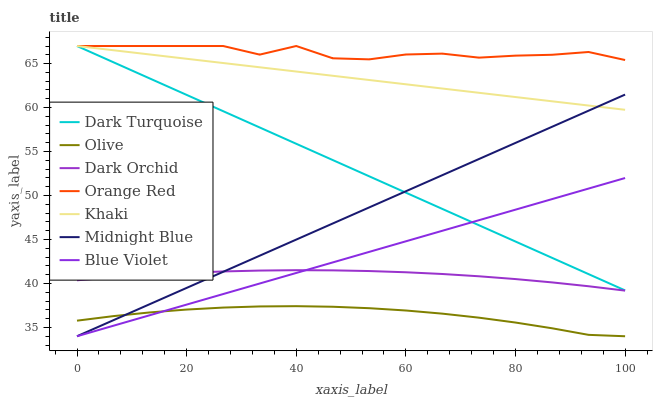Does Midnight Blue have the minimum area under the curve?
Answer yes or no. No. Does Midnight Blue have the maximum area under the curve?
Answer yes or no. No. Is Midnight Blue the smoothest?
Answer yes or no. No. Is Midnight Blue the roughest?
Answer yes or no. No. Does Dark Turquoise have the lowest value?
Answer yes or no. No. Does Midnight Blue have the highest value?
Answer yes or no. No. Is Midnight Blue less than Orange Red?
Answer yes or no. Yes. Is Orange Red greater than Olive?
Answer yes or no. Yes. Does Midnight Blue intersect Orange Red?
Answer yes or no. No. 